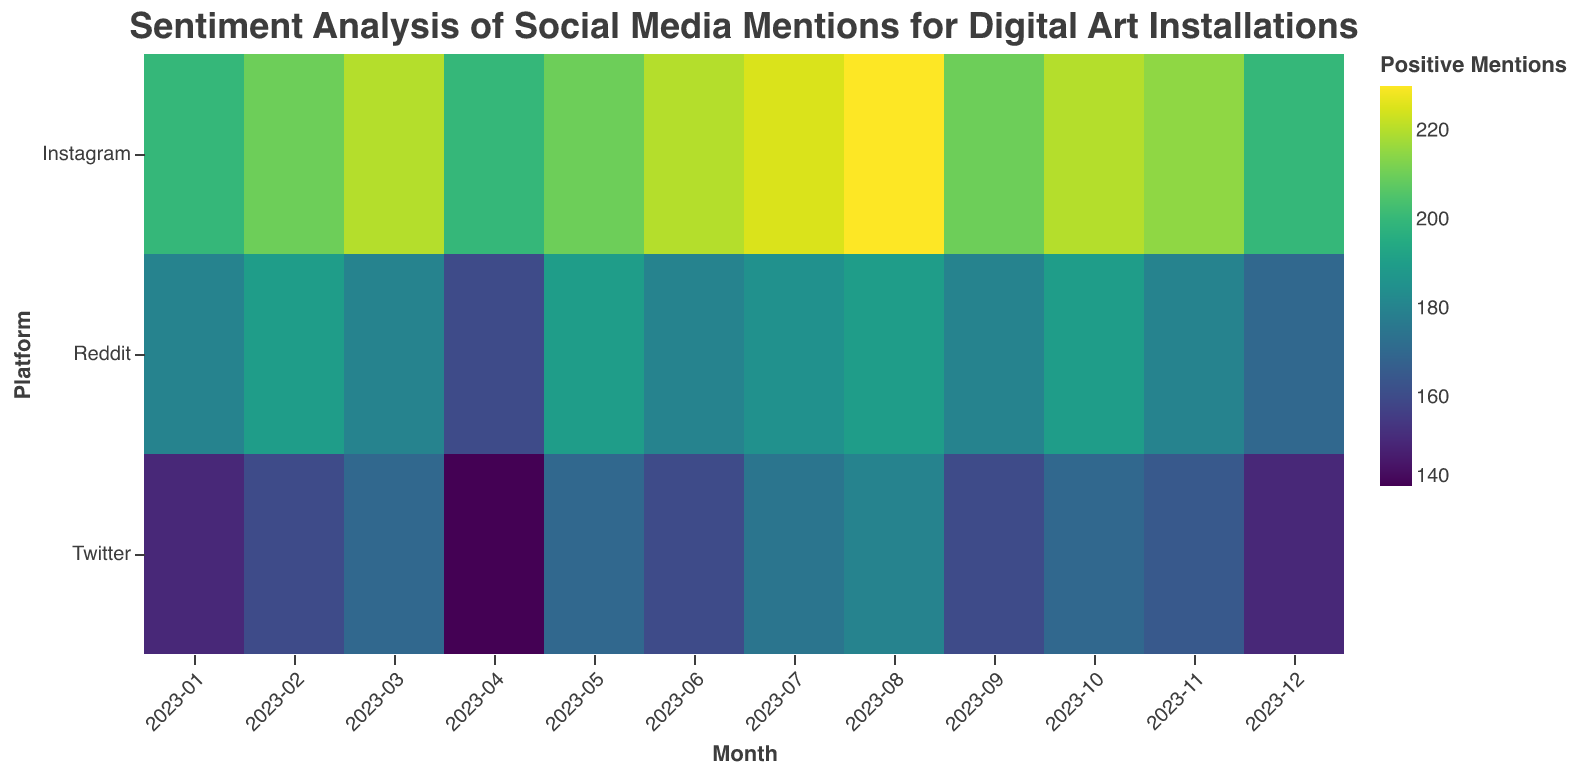What is the title of the figure? The title is displayed at the top center of the figure. It reads, "Sentiment Analysis of Social Media Mentions for Digital Art Installations"
Answer: Sentiment Analysis of Social Media Mentions for Digital Art Installations Which platform had the highest number of positive mentions in August 2023? By observing the color intensity in August 2023, Instagram has the highest hue, indicating the most positive mentions.
Answer: Instagram Which month had the lowest number of positive mentions for Reddit? Look for the month with the least color intensity for Reddit. In April 2023, Reddit has the lowest count of positive mentions.
Answer: April 2023 What is the general trend of positive mentions on Instagram from January to December 2023? The color intensity for Instagram shows a darker hue as months progress from January to December, indicating that positive mentions generally increase.
Answer: Increase Compare the number of positive mentions on Twitter and Instagram in March 2023. Which has more? Observing the color intensity for March 2023, Instagram has a darker hue compared to Twitter, indicating more positive mentions on Instagram.
Answer: Instagram How do neutral mentions compare across all platforms in July 2023? The figure doesn't include neutral sentiment in color encoding. It would require viewing the data directly to answer questions about neutral mentions.
Answer: Not color-coded What is the difference in the highest number of positive mentions between Reddit and Instagram across any month? The highest number for Instagram is 230 (August) and 190 for Reddit (October). The difference is 230 - 190.
Answer: 40 Across which month did Twitter see an increase in positive mentions followed by a decrease? Examining the shades for Twitter, there's an increase from June to July (160 to 175) and then a decrease from July to September (175 to 160).
Answer: July to September Which platform had the most stable (least variable) positive mentions throughout the year? By comparing monthly variations in color for each platform, Twitter shows relatively consistent mid-range hues, indicating more stable mentions.
Answer: Twitter In which month did all three platforms (Twitter, Instagram, Reddit) witness an increase in positive mentions compared to the previous month? Comparing color intensities month-by-month, in March 2023, all platforms show a darker hue compared to February 2023, indicating an increase in positive mentions.
Answer: March 2023 